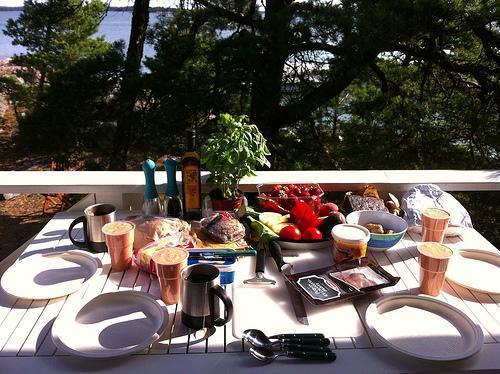How many mugs are there?
Give a very brief answer. 2. 